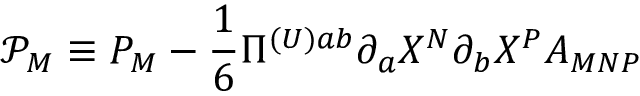<formula> <loc_0><loc_0><loc_500><loc_500>\mathcal { P } _ { M } \mathcal { \equiv } P _ { M } - \frac { 1 } { 6 } \Pi ^ { ( U ) a b } \partial _ { a } X ^ { N } \partial _ { b } X ^ { P } A _ { M N P }</formula> 